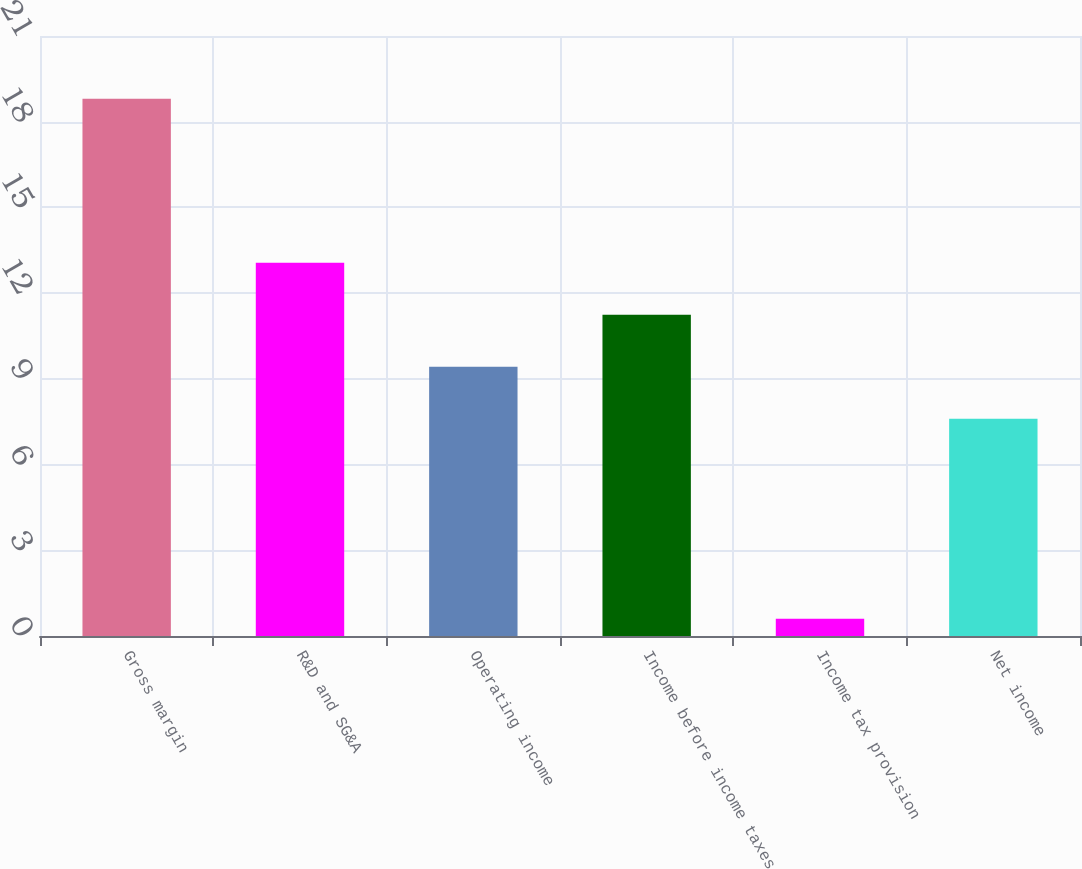Convert chart to OTSL. <chart><loc_0><loc_0><loc_500><loc_500><bar_chart><fcel>Gross margin<fcel>R&D and SG&A<fcel>Operating income<fcel>Income before income taxes<fcel>Income tax provision<fcel>Net income<nl><fcel>18.8<fcel>13.06<fcel>9.42<fcel>11.24<fcel>0.6<fcel>7.6<nl></chart> 